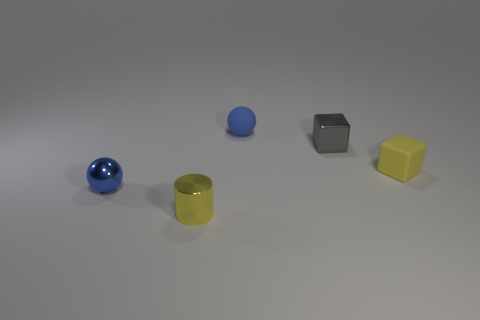Add 5 small gray metal blocks. How many objects exist? 10 Subtract all cylinders. How many objects are left? 4 Add 5 small metallic things. How many small metallic things are left? 8 Add 2 small shiny cylinders. How many small shiny cylinders exist? 3 Subtract 0 blue blocks. How many objects are left? 5 Subtract all yellow rubber blocks. Subtract all yellow objects. How many objects are left? 2 